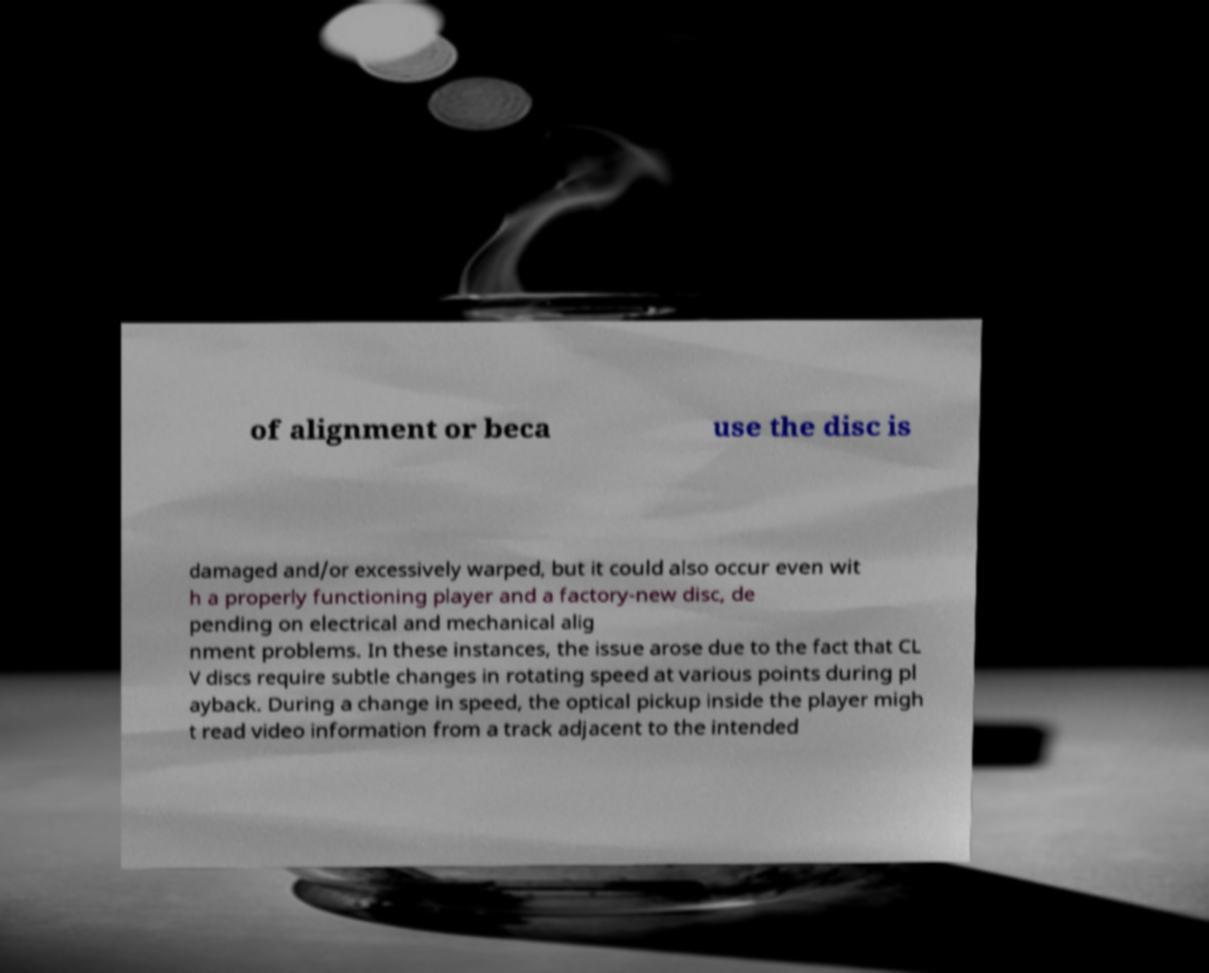For documentation purposes, I need the text within this image transcribed. Could you provide that? of alignment or beca use the disc is damaged and/or excessively warped, but it could also occur even wit h a properly functioning player and a factory-new disc, de pending on electrical and mechanical alig nment problems. In these instances, the issue arose due to the fact that CL V discs require subtle changes in rotating speed at various points during pl ayback. During a change in speed, the optical pickup inside the player migh t read video information from a track adjacent to the intended 